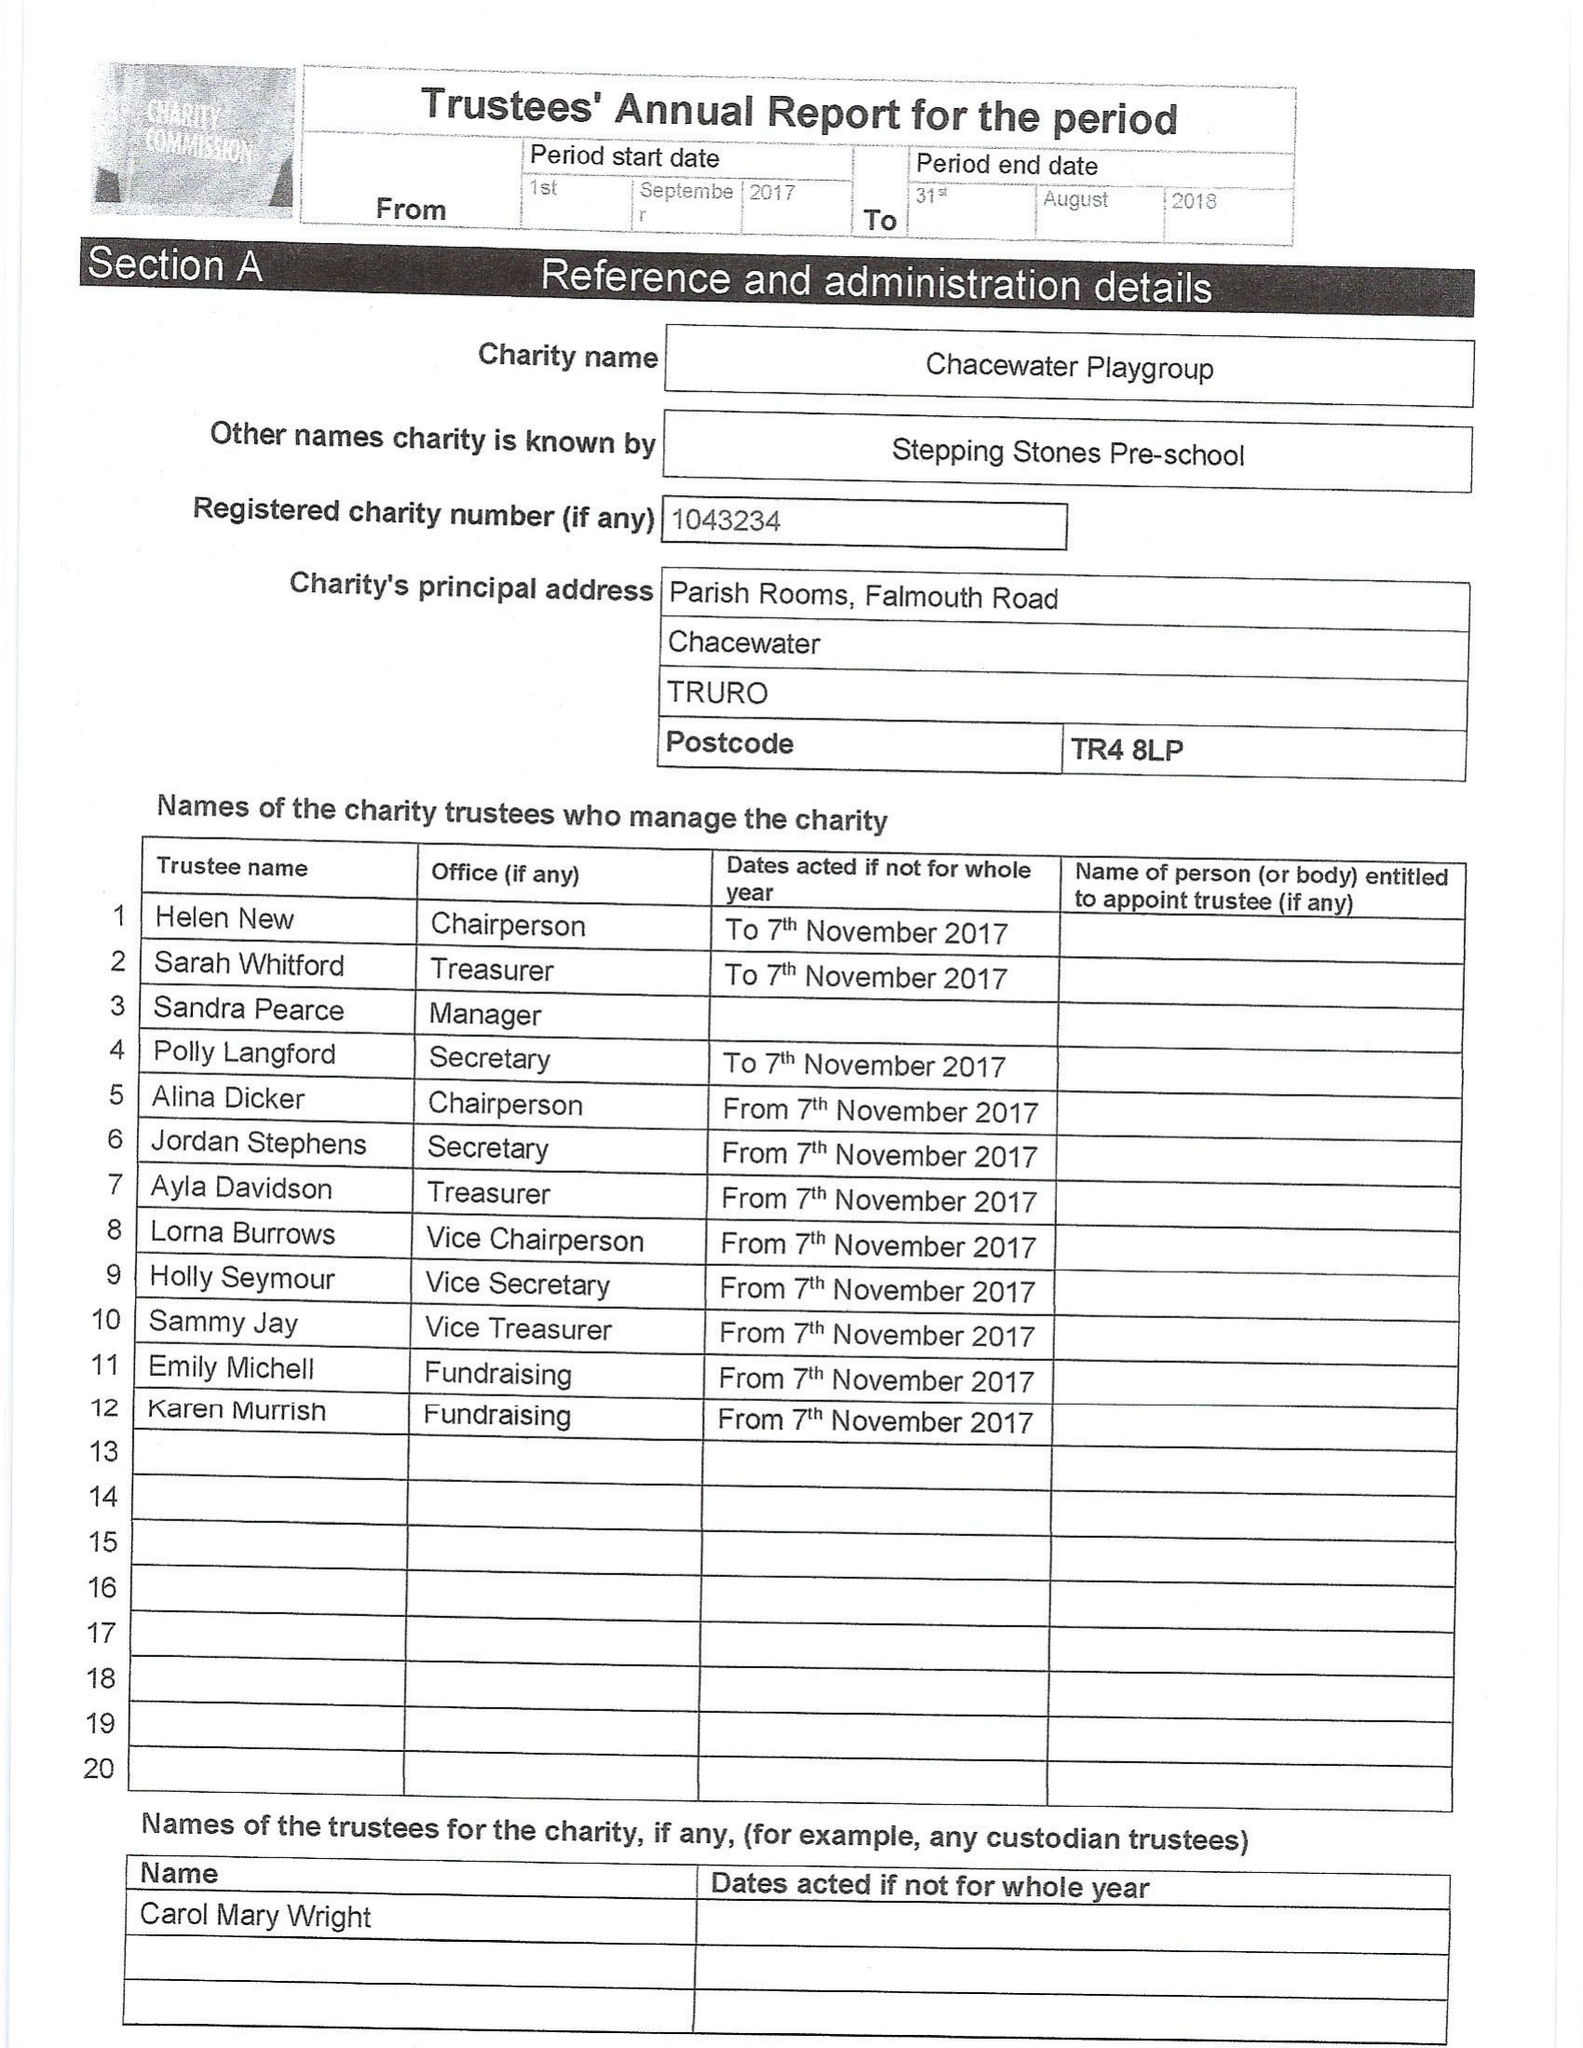What is the value for the address__street_line?
Answer the question using a single word or phrase. FALMOUTH ROAD 